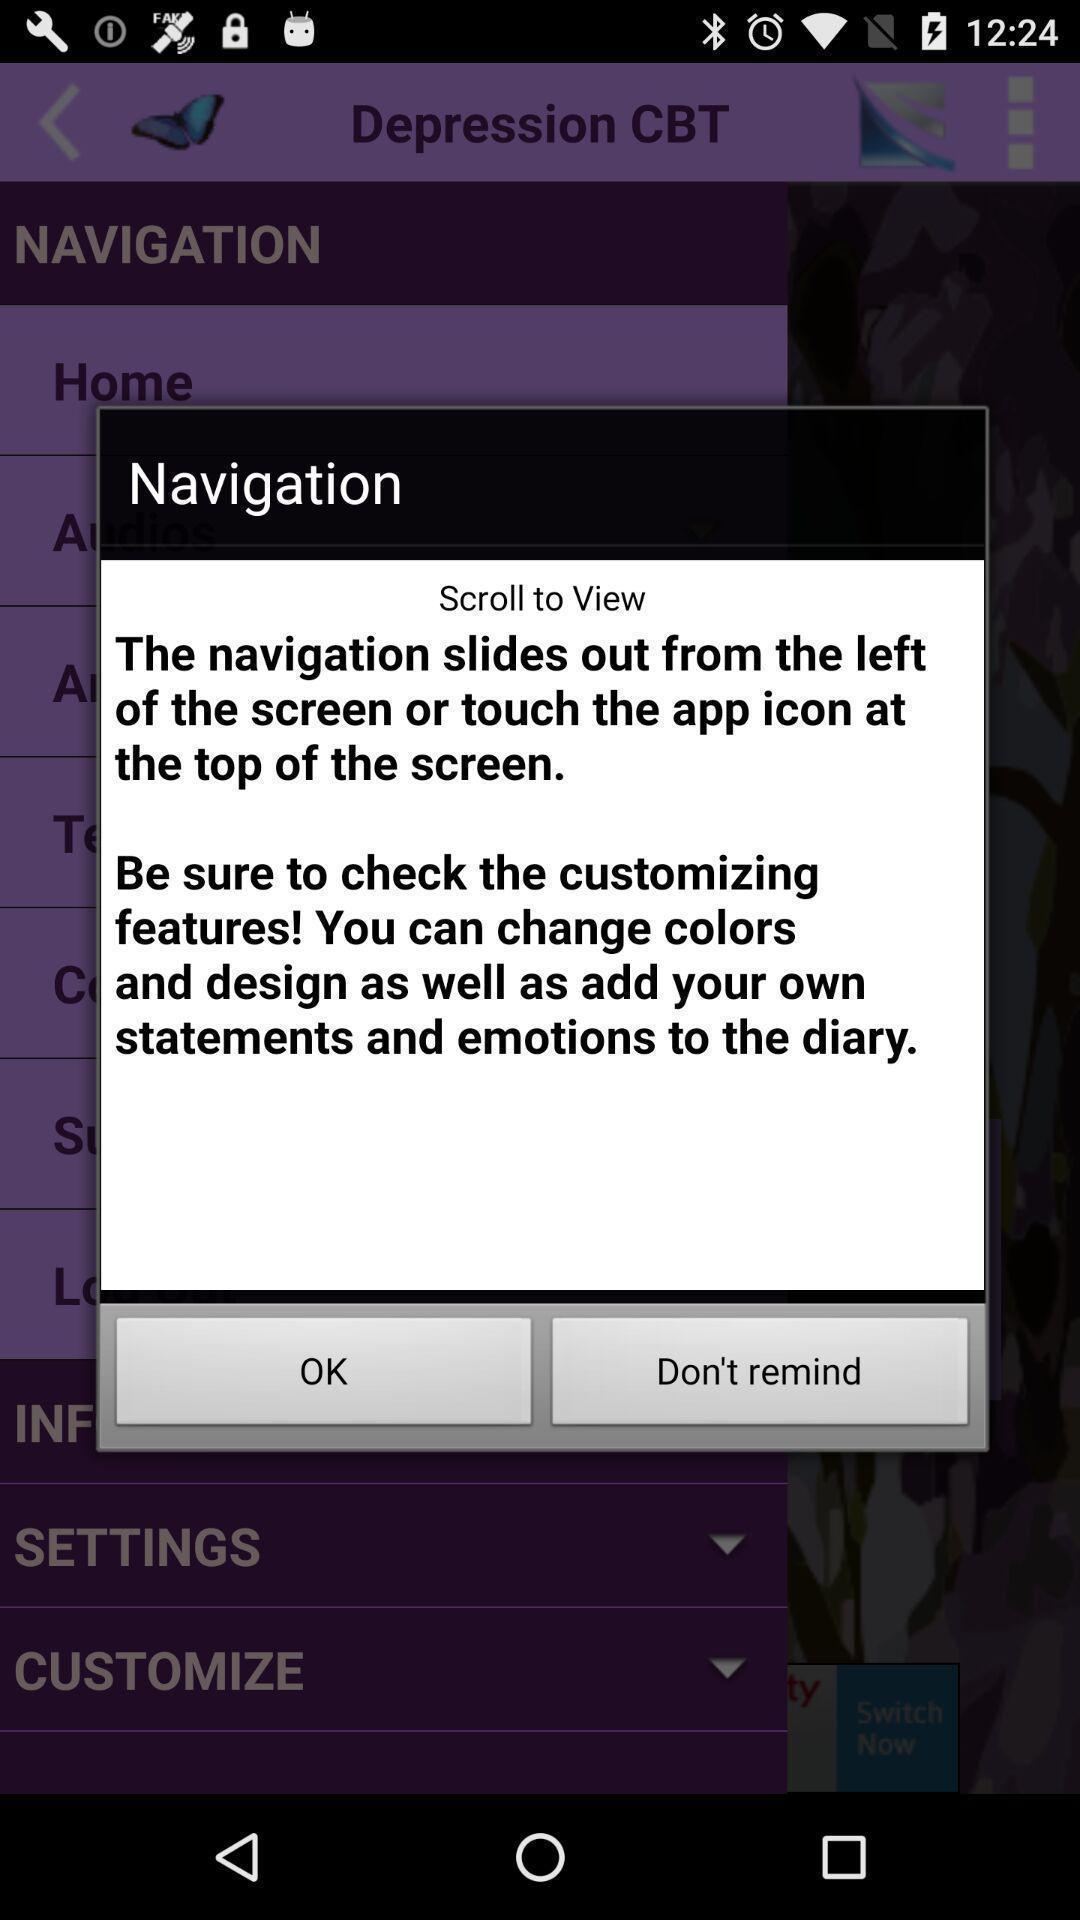Describe the visual elements of this screenshot. Pop-up with info in a mental health monitoring app. 